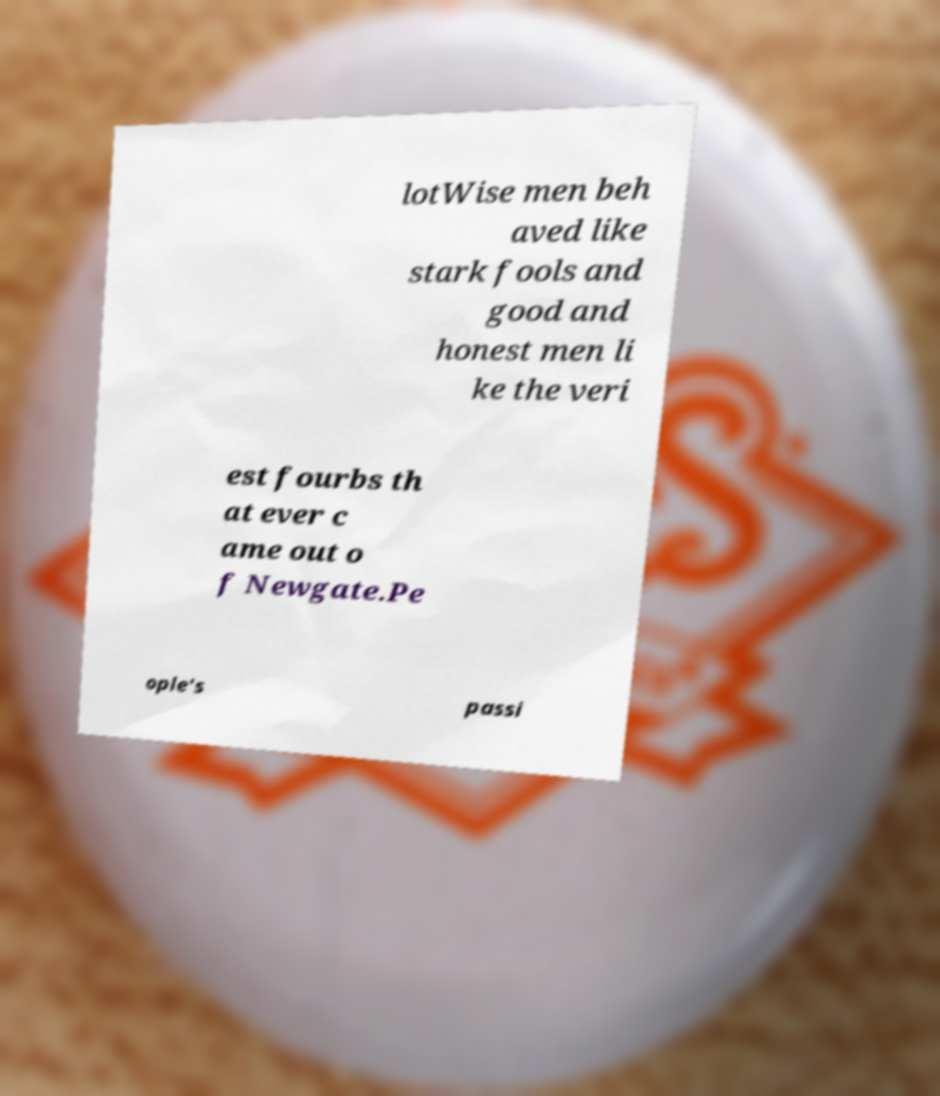There's text embedded in this image that I need extracted. Can you transcribe it verbatim? lotWise men beh aved like stark fools and good and honest men li ke the veri est fourbs th at ever c ame out o f Newgate.Pe ople's passi 